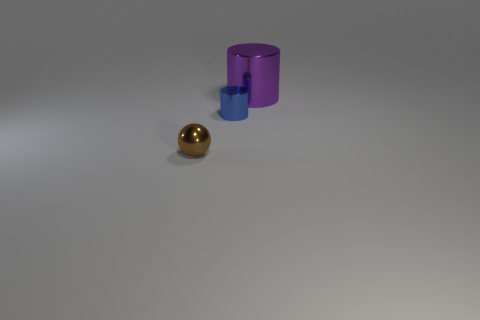What is the color of the metallic cylinder that is the same size as the brown object?
Offer a terse response. Blue. Does the purple thing have the same size as the brown object?
Keep it short and to the point. No. The object that is both left of the big metal object and on the right side of the tiny brown metal sphere is what color?
Keep it short and to the point. Blue. Is the number of brown things that are behind the small brown object greater than the number of brown shiny spheres behind the blue shiny thing?
Give a very brief answer. No. The blue thing that is made of the same material as the big cylinder is what size?
Provide a succinct answer. Small. Is there any other thing that is the same color as the big metallic cylinder?
Your answer should be compact. No. What is the shape of the tiny blue object that is the same material as the purple thing?
Your response must be concise. Cylinder. How many purple shiny objects are behind the shiny thing that is left of the cylinder that is on the left side of the purple object?
Provide a short and direct response. 1. The metal thing that is both to the right of the ball and on the left side of the purple object has what shape?
Make the answer very short. Cylinder. Are there fewer metallic spheres behind the purple metallic object than small purple spheres?
Your answer should be very brief. No. 